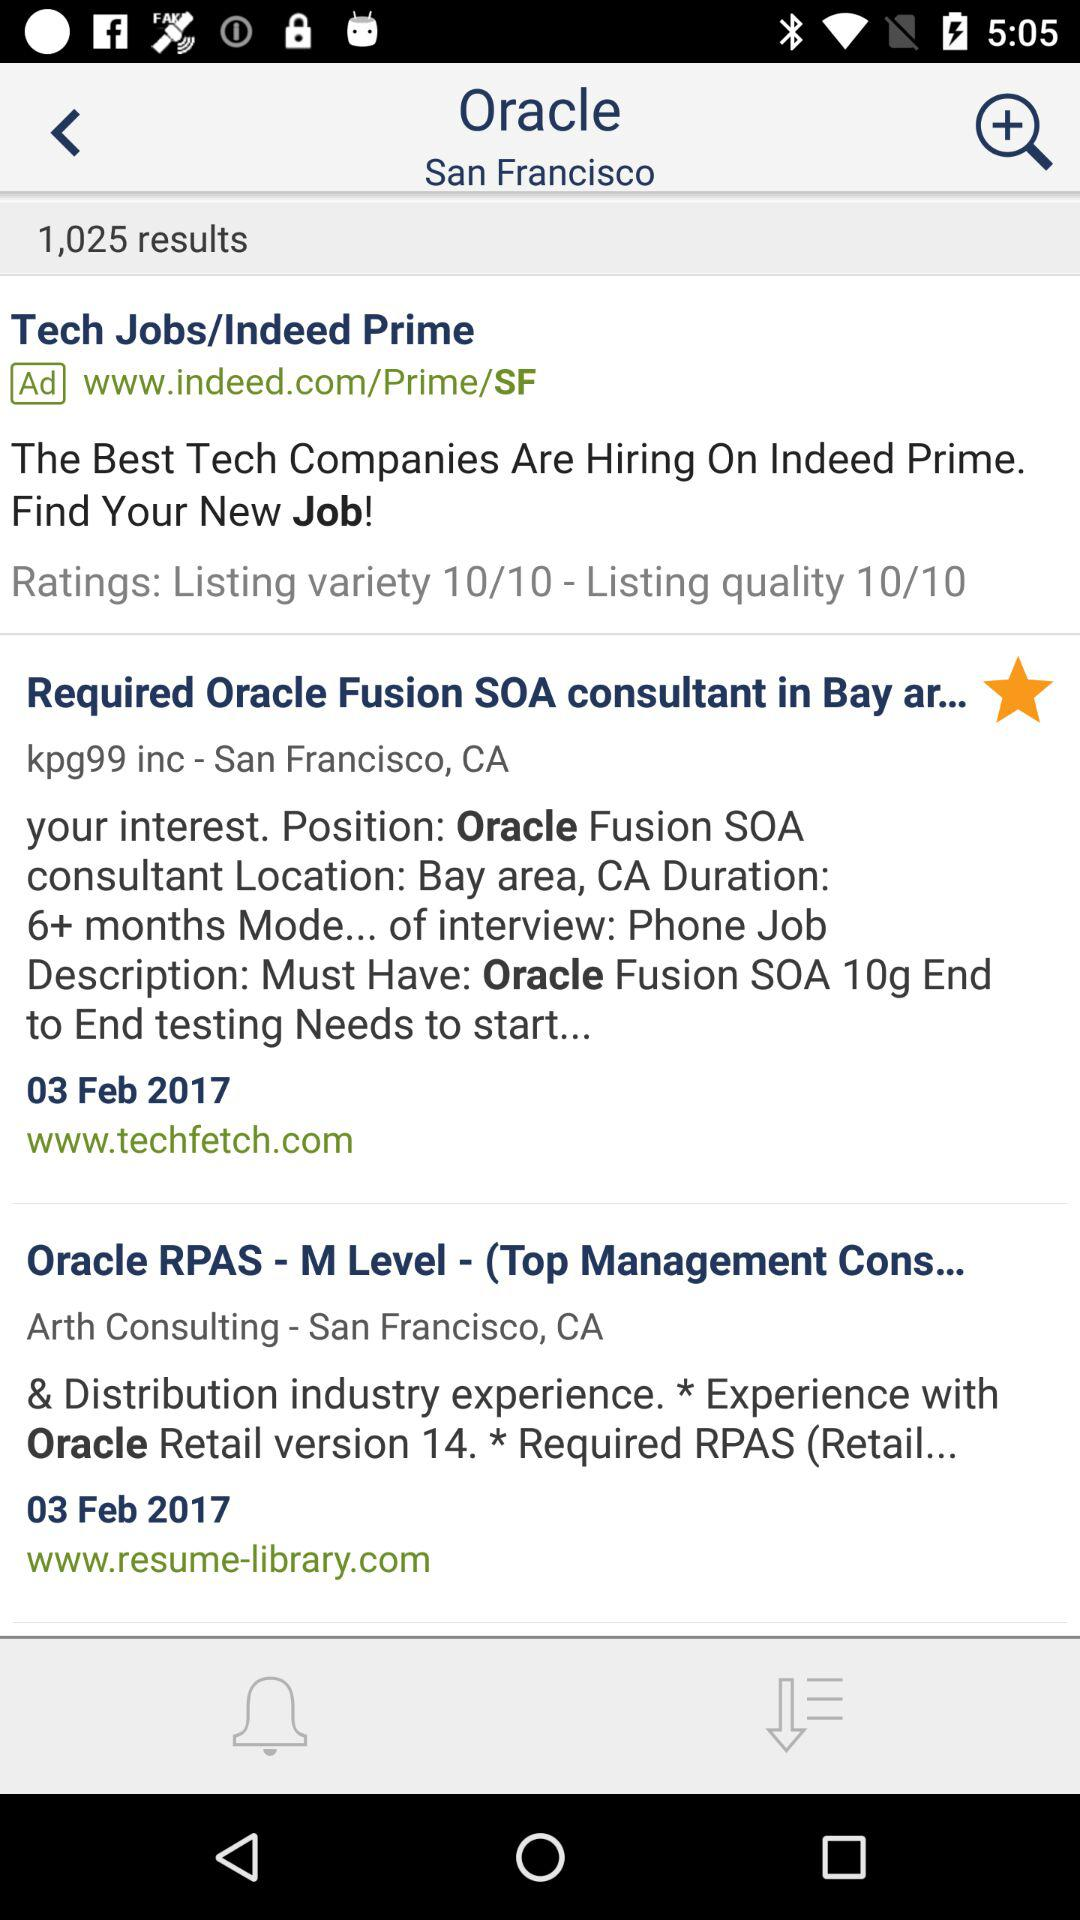How many of the results are ads?
Answer the question using a single word or phrase. 1 